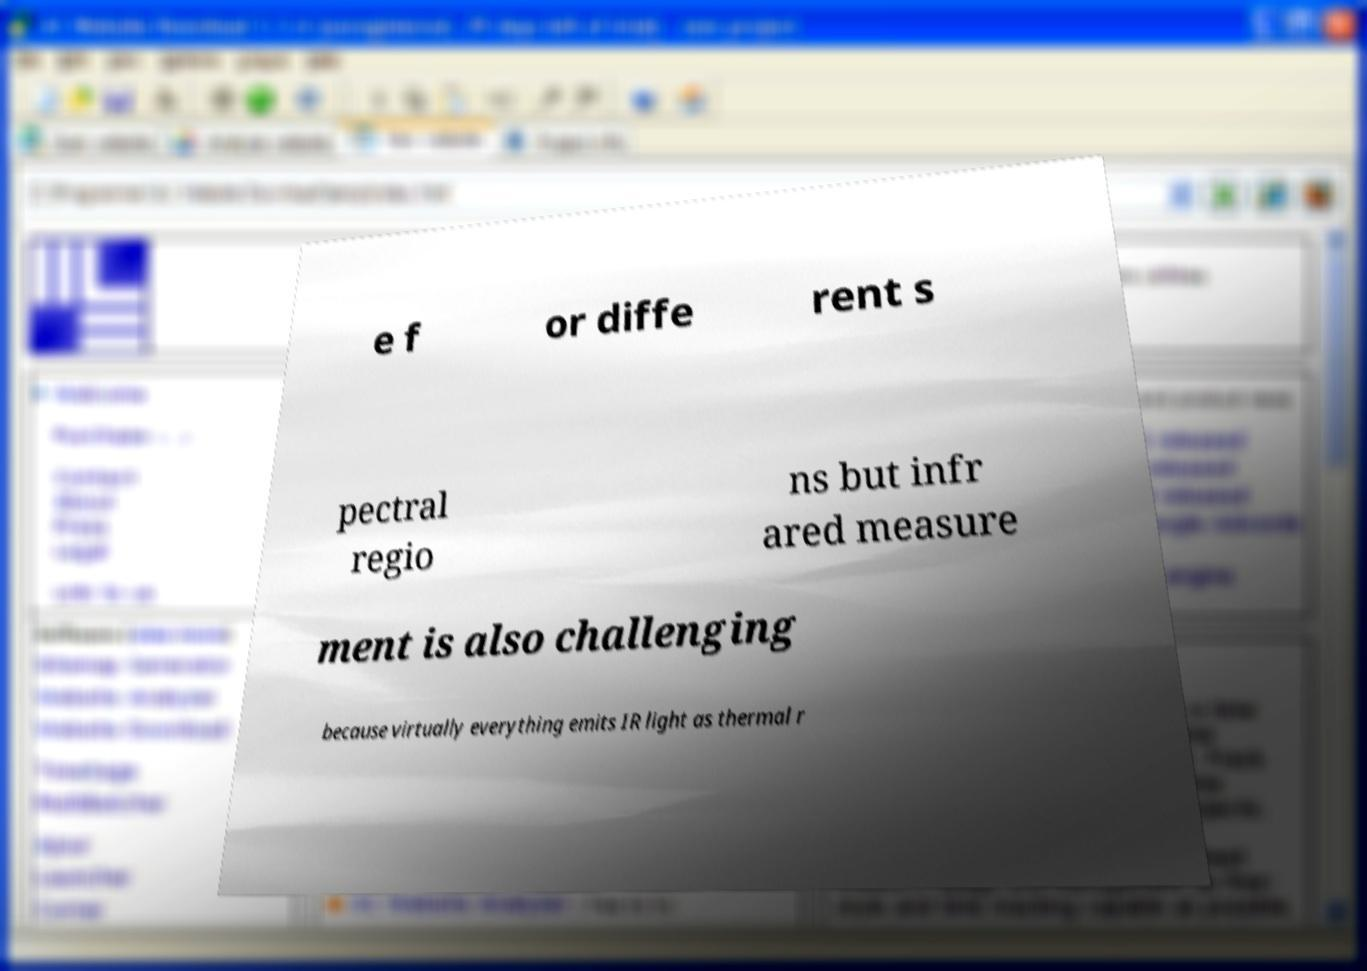I need the written content from this picture converted into text. Can you do that? e f or diffe rent s pectral regio ns but infr ared measure ment is also challenging because virtually everything emits IR light as thermal r 